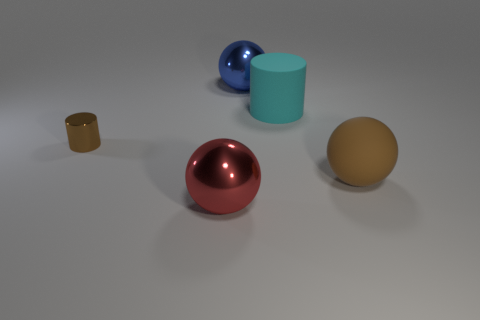What number of things are either cyan things that are on the right side of the small shiny object or large metallic spheres behind the tiny metallic object?
Provide a succinct answer. 2. What is the shape of the blue thing?
Your answer should be very brief. Sphere. How many other things are made of the same material as the cyan object?
Your response must be concise. 1. There is another metal thing that is the same shape as the cyan object; what size is it?
Keep it short and to the point. Small. The ball right of the cylinder that is on the right side of the big ball that is to the left of the big blue metallic object is made of what material?
Your answer should be compact. Rubber. Are any big blue matte things visible?
Your answer should be compact. No. There is a small shiny cylinder; does it have the same color as the big sphere to the right of the blue object?
Keep it short and to the point. Yes. The big rubber cylinder is what color?
Keep it short and to the point. Cyan. The large object that is the same shape as the small brown thing is what color?
Offer a terse response. Cyan. Does the cyan object have the same shape as the tiny brown metallic thing?
Make the answer very short. Yes. 